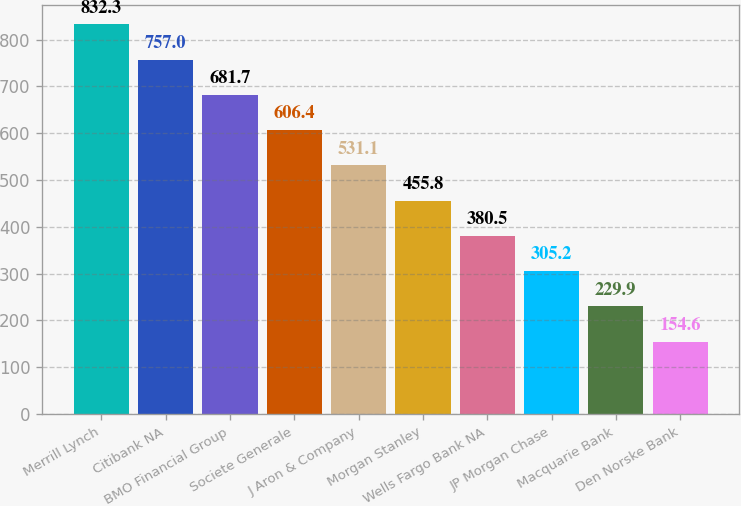Convert chart. <chart><loc_0><loc_0><loc_500><loc_500><bar_chart><fcel>Merrill Lynch<fcel>Citibank NA<fcel>BMO Financial Group<fcel>Societe Generale<fcel>J Aron & Company<fcel>Morgan Stanley<fcel>Wells Fargo Bank NA<fcel>JP Morgan Chase<fcel>Macquarie Bank<fcel>Den Norske Bank<nl><fcel>832.3<fcel>757<fcel>681.7<fcel>606.4<fcel>531.1<fcel>455.8<fcel>380.5<fcel>305.2<fcel>229.9<fcel>154.6<nl></chart> 